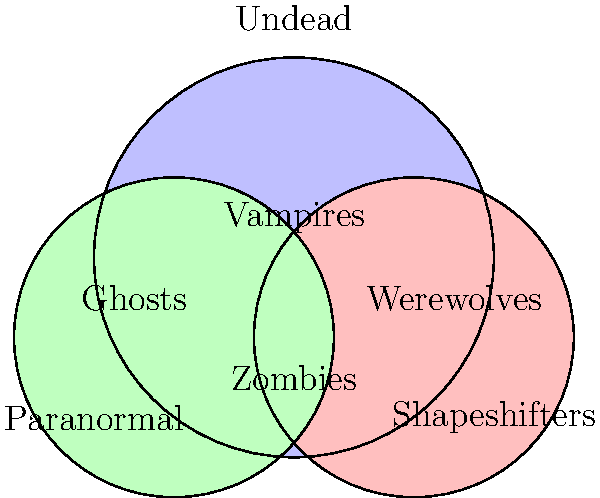Analyze the Venn diagram depicting various horror monster classifications. Which type of monster would be considered both Undead and a Shapeshifter, but not Paranormal? To answer this question, we need to analyze the Venn diagram and understand the classifications:

1. The diagram consists of three overlapping circles representing Undead, Shapeshifters, and Paranormal entities.

2. We need to identify a monster that falls into the intersection of Undead and Shapeshifters, but not Paranormal.

3. Let's examine each region:
   - Ghosts: Paranormal and Undead
   - Zombies: Only Undead
   - Werewolves: Only Shapeshifters
   - Vampires: In the intersection of all three categories

4. Vampires are the only monster type that appears in the intersection of Undead and Shapeshifters.

5. However, Vampires are also classified as Paranormal in this diagram.

6. There is no explicitly labeled monster type that fits the criteria of being both Undead and a Shapeshifter, but not Paranormal.

7. In horror literature, vampires are often portrayed with varying abilities and characteristics. Some interpretations of vampires might not include paranormal aspects, focusing solely on their undead nature and shapeshifting abilities.

8. Therefore, we can conclude that a specific subset of vampires – those without paranormal attributes – would fit the description in the question.
Answer: Non-paranormal vampires 